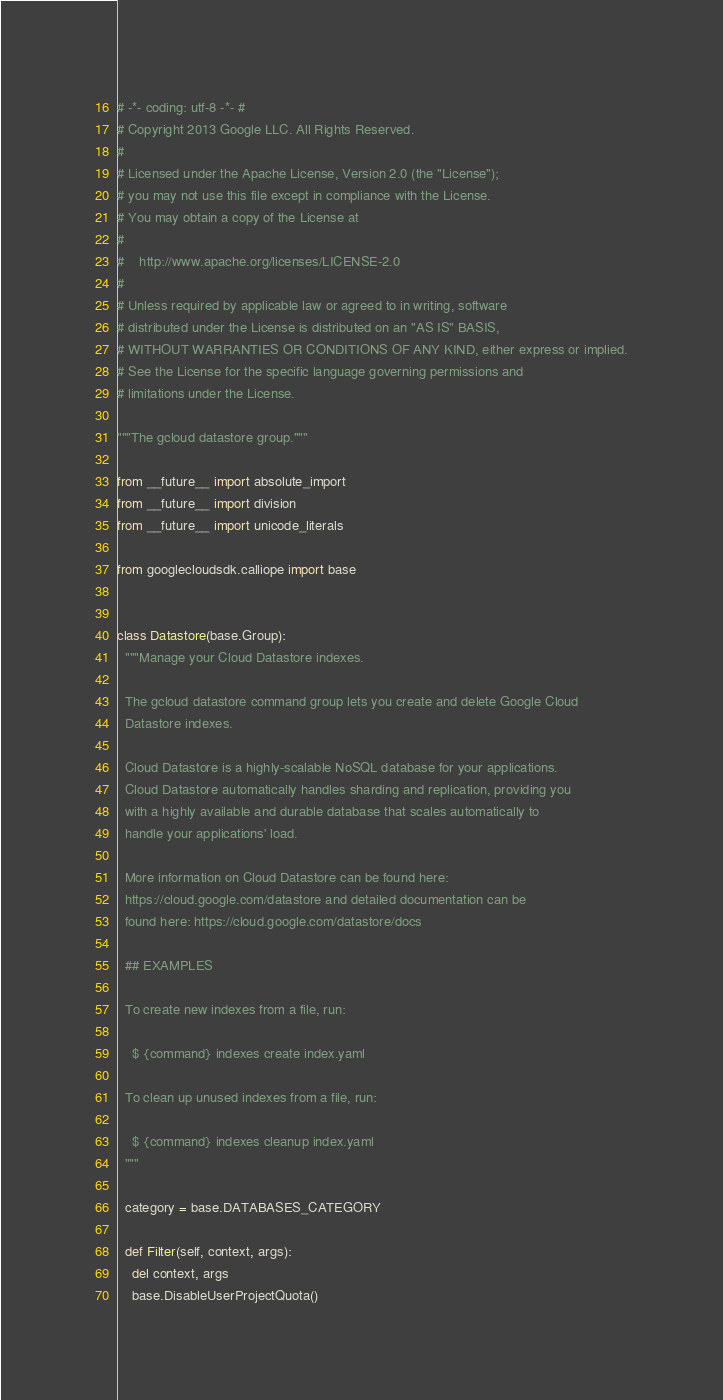<code> <loc_0><loc_0><loc_500><loc_500><_Python_># -*- coding: utf-8 -*- #
# Copyright 2013 Google LLC. All Rights Reserved.
#
# Licensed under the Apache License, Version 2.0 (the "License");
# you may not use this file except in compliance with the License.
# You may obtain a copy of the License at
#
#    http://www.apache.org/licenses/LICENSE-2.0
#
# Unless required by applicable law or agreed to in writing, software
# distributed under the License is distributed on an "AS IS" BASIS,
# WITHOUT WARRANTIES OR CONDITIONS OF ANY KIND, either express or implied.
# See the License for the specific language governing permissions and
# limitations under the License.

"""The gcloud datastore group."""

from __future__ import absolute_import
from __future__ import division
from __future__ import unicode_literals

from googlecloudsdk.calliope import base


class Datastore(base.Group):
  """Manage your Cloud Datastore indexes.

  The gcloud datastore command group lets you create and delete Google Cloud
  Datastore indexes.

  Cloud Datastore is a highly-scalable NoSQL database for your applications.
  Cloud Datastore automatically handles sharding and replication, providing you
  with a highly available and durable database that scales automatically to
  handle your applications' load.

  More information on Cloud Datastore can be found here:
  https://cloud.google.com/datastore and detailed documentation can be
  found here: https://cloud.google.com/datastore/docs

  ## EXAMPLES

  To create new indexes from a file, run:

    $ {command} indexes create index.yaml

  To clean up unused indexes from a file, run:

    $ {command} indexes cleanup index.yaml
  """

  category = base.DATABASES_CATEGORY

  def Filter(self, context, args):
    del context, args
    base.DisableUserProjectQuota()
</code> 